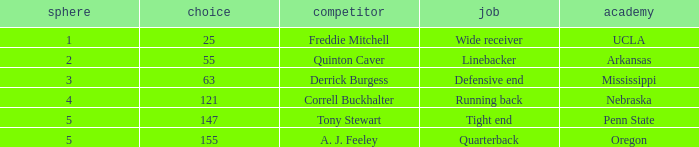What position did the player who was picked in round 3 play? Defensive end. 